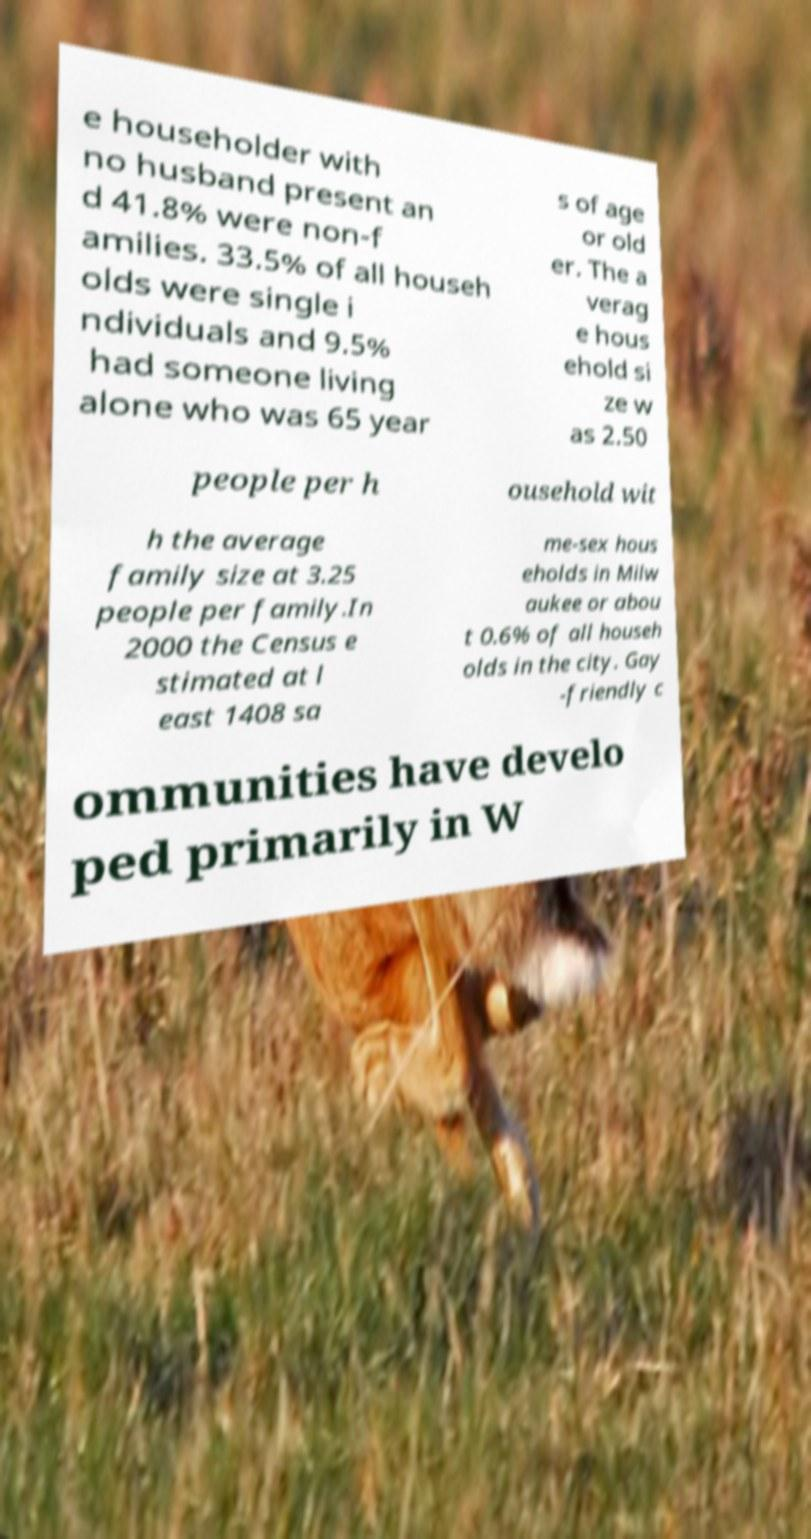Can you accurately transcribe the text from the provided image for me? e householder with no husband present an d 41.8% were non-f amilies. 33.5% of all househ olds were single i ndividuals and 9.5% had someone living alone who was 65 year s of age or old er. The a verag e hous ehold si ze w as 2.50 people per h ousehold wit h the average family size at 3.25 people per family.In 2000 the Census e stimated at l east 1408 sa me-sex hous eholds in Milw aukee or abou t 0.6% of all househ olds in the city. Gay -friendly c ommunities have develo ped primarily in W 